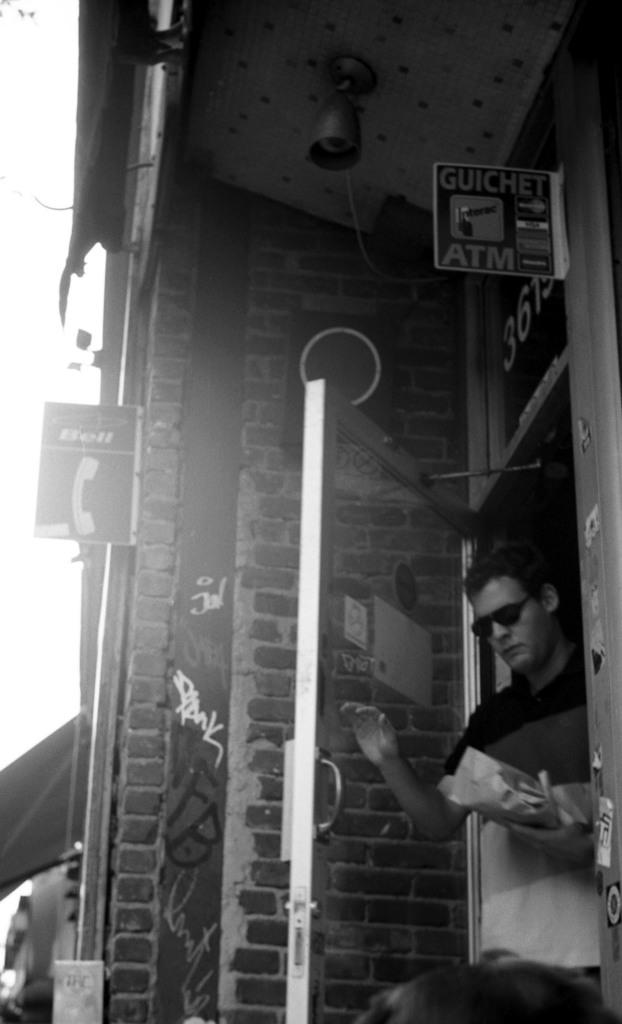Who or what is in the image? There is a person in the image. What is the person doing or standing near in the image? The person is in front of a door. What is the person is wearing? The person is wearing clothes and sunglasses. What else can be seen in the image besides the person? There is a wall in the middle of the image. How many clocks are hanging on the wall in the image? There are no clocks visible in the image; only a wall is present. Can you see a giraffe in the image? No, there is no giraffe present in the image. 